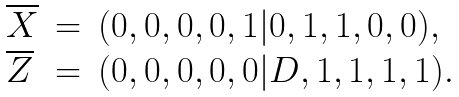Convert formula to latex. <formula><loc_0><loc_0><loc_500><loc_500>\begin{array} { l c l } \overline { X } & = & ( 0 , 0 , 0 , 0 , 1 | 0 , 1 , 1 , 0 , 0 ) , \\ \overline { Z } & = & ( 0 , 0 , 0 , 0 , 0 | D , 1 , 1 , 1 , 1 ) . \end{array}</formula> 